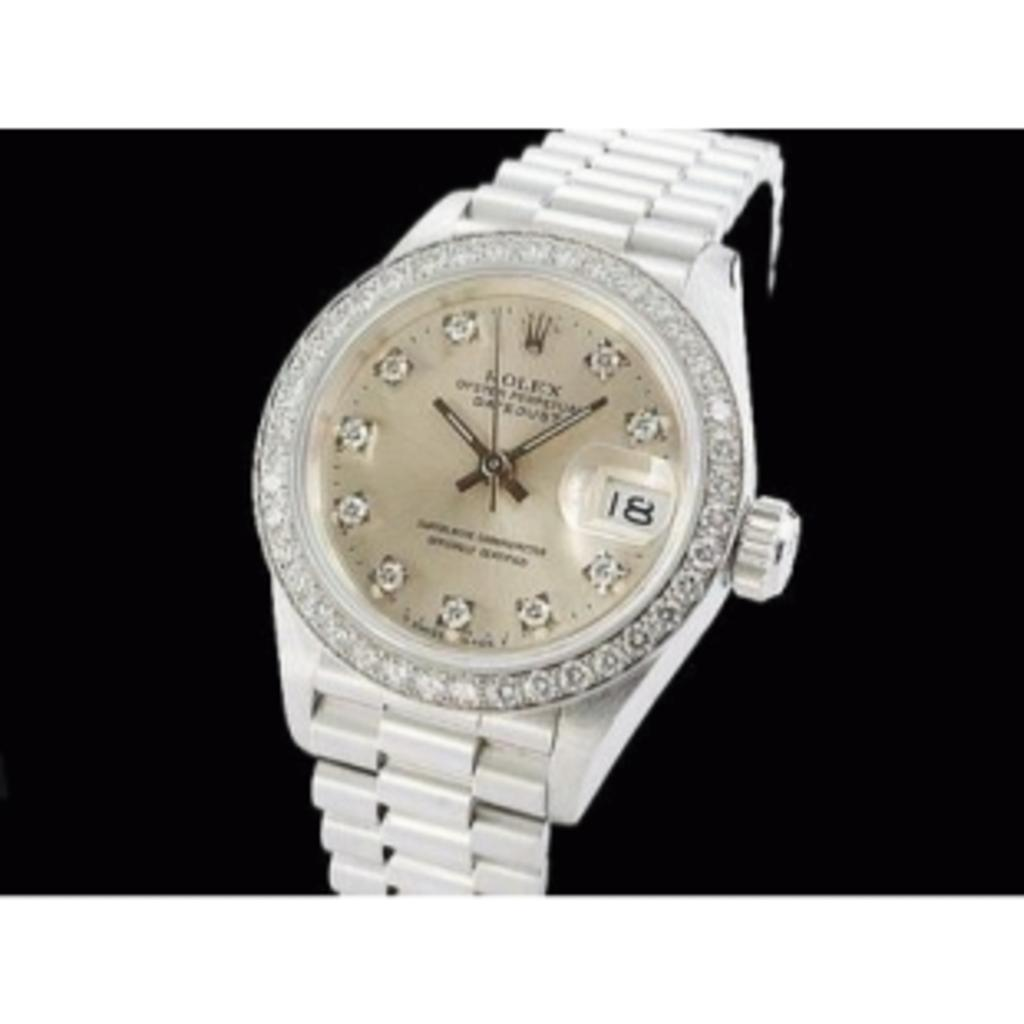<image>
Offer a succinct explanation of the picture presented. A white Rolex watch with diamonds has the number 18 on it. 